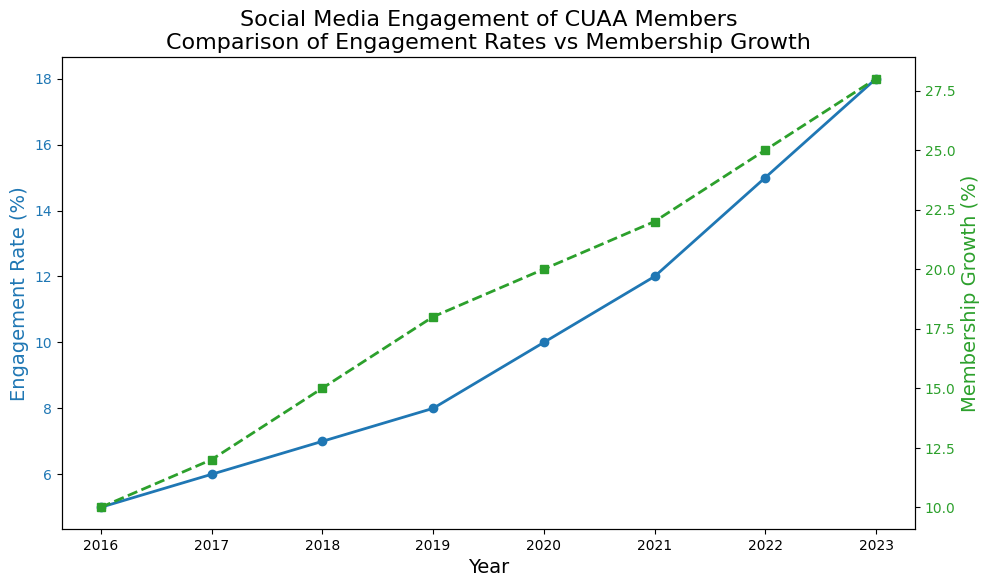What trend is observed in the Engagement Rate from 2016 to 2023? The Engagement Rate increases steadily over the years from 5% in 2016 to 18% in 2023. This visible upward trend implies that social media engagement among CUAA members has been consistently growing.
Answer: An increasing trend In which year was the Membership Growth (%) exactly double the Engagement Rate (%)? To find the year where Membership Growth is double the Engagement Rate, look at the years and check the ratios. In 2019, the Engagement Rate is 8% and Membership Growth is 18%, which is close but not exact. Checking 2020, Engagement Rate is 10% and Membership Growth is 20%, which is exactly double.
Answer: 2020 How does the slope of the Engagement Rate line compare to the slope of the Membership Growth line? To compare the slopes, observe the steepness of the lines. The Engagement Rate line appears to be increasing more gradually compared to the more sharply increasing Membership Growth line, especially noticeable from 2020 to 2023.
Answer: Membership Growth has a steeper slope Is there a year where both Engagement Rate and Membership Growth increased by exactly 3% from the previous year? Look for consecutive years where both values increase by 3%. From 2022 to 2023, Engagement Rate increases from 15% to 18% and Membership Growth from 25% to 28%, both increasing by exactly 3%.
Answer: 2023 What is the difference in Membership Growth (%) between 2016 and 2023? Subtract the Membership Growth in 2016 from that in 2023. The Membership Growth in 2016 is 10% and in 2023 is 28%. So, 28% - 10% = 18%.
Answer: 18% How does the visual appearance of the marker styles differ between Engagement Rate and Membership Growth? The markers for the Engagement Rate line are circles and have a solid line, while the markers for the Membership Growth line are squares and have a dashed line. This visual distinction helps differentiate the two data sets on the plot.
Answer: Circles with solid line vs. squares with dashed line What is the average Engagement Rate (%) over the time period? To find the average Engagement Rate, sum all Engagement Rate values and divide by the number of years. (5 + 6 + 7 + 8 + 10 + 12 + 15 + 18) / 8 = 81 / 8 = 10.125%.
Answer: 10.125% How much did the Engagement Rate increase from 2016 to 2023? Subtract the Engagement Rate in 2016 from the Engagement Rate in 2023. The Engagement Rate in 2016 is 5% and in 2023 is 18%. So, 18% - 5% = 13%.
Answer: 13% Which year shows the largest single-year increase in Membership Growth (%)? By comparing the year-over-year differences in Membership Growth, the largest increase is found from 2017 (12%) to 2018 (15%), which is 3%. Checking every year, 2019 (18%) to 2020 (20%) is 2%, and 2021 (22%) to 2022 (25%) is 3%. The consistent yearly increase doesn't have a single greater value than another, implying a steady growth rate.
Answer: No single largest increase, consistent growth What does the title "Social Media Engagement of CUAA Members Comparison of Engagement Rates vs Membership Growth" imply about the focus of the plot? The title suggests that the focus of the plot is on comparing two key metrics, Engagement Rates and Membership Growth, among CUAA members over the given period. The dual y-axis presentation highlights trends and possible correlations between these metrics.
Answer: Comparison of Engagement Rates and Membership Growth 